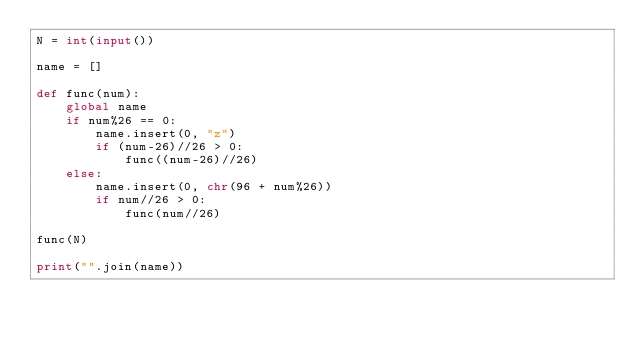<code> <loc_0><loc_0><loc_500><loc_500><_Python_>N = int(input())

name = []

def func(num):
    global name
    if num%26 == 0:
        name.insert(0, "z")
        if (num-26)//26 > 0:
            func((num-26)//26)
    else:
        name.insert(0, chr(96 + num%26))
        if num//26 > 0:
            func(num//26)

func(N)

print("".join(name))</code> 